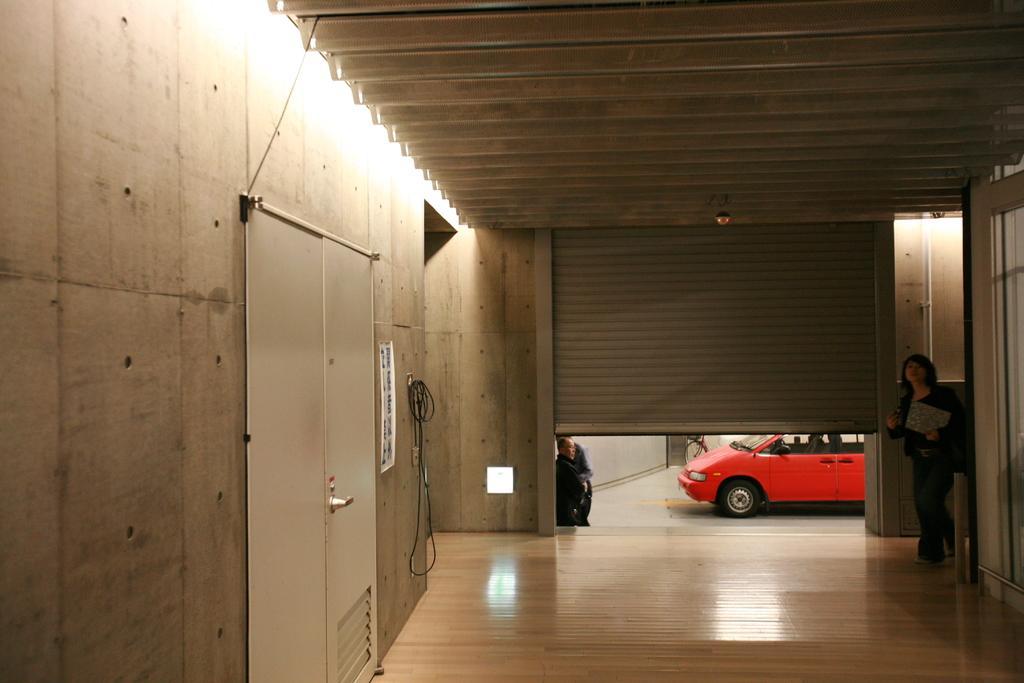How would you summarize this image in a sentence or two? In this image we can see a woman walking on the ground. We can also see a door, wall, wires and a roof. On the backside we can see a shutter, some people standing and a vehicle on the ground. 